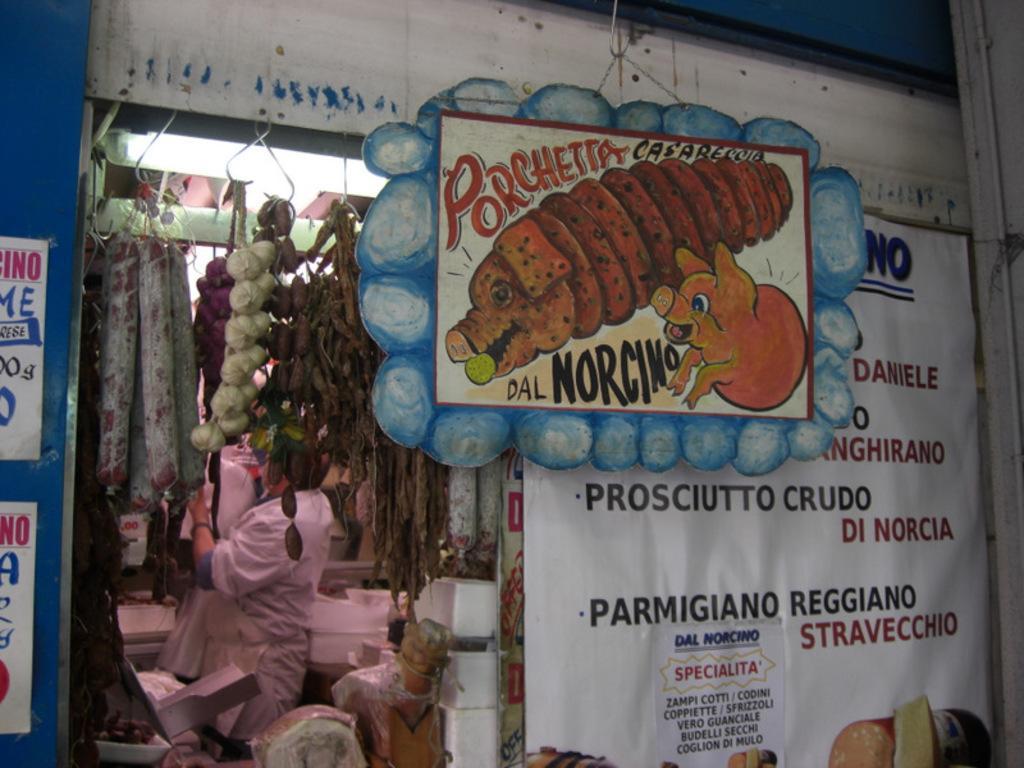Could you give a brief overview of what you see in this image? In this image there is a shop, that shop is covered with banners, on that banners some text is written and there are two image on that banner, in the background there are few items and a man is standing in a shop. 